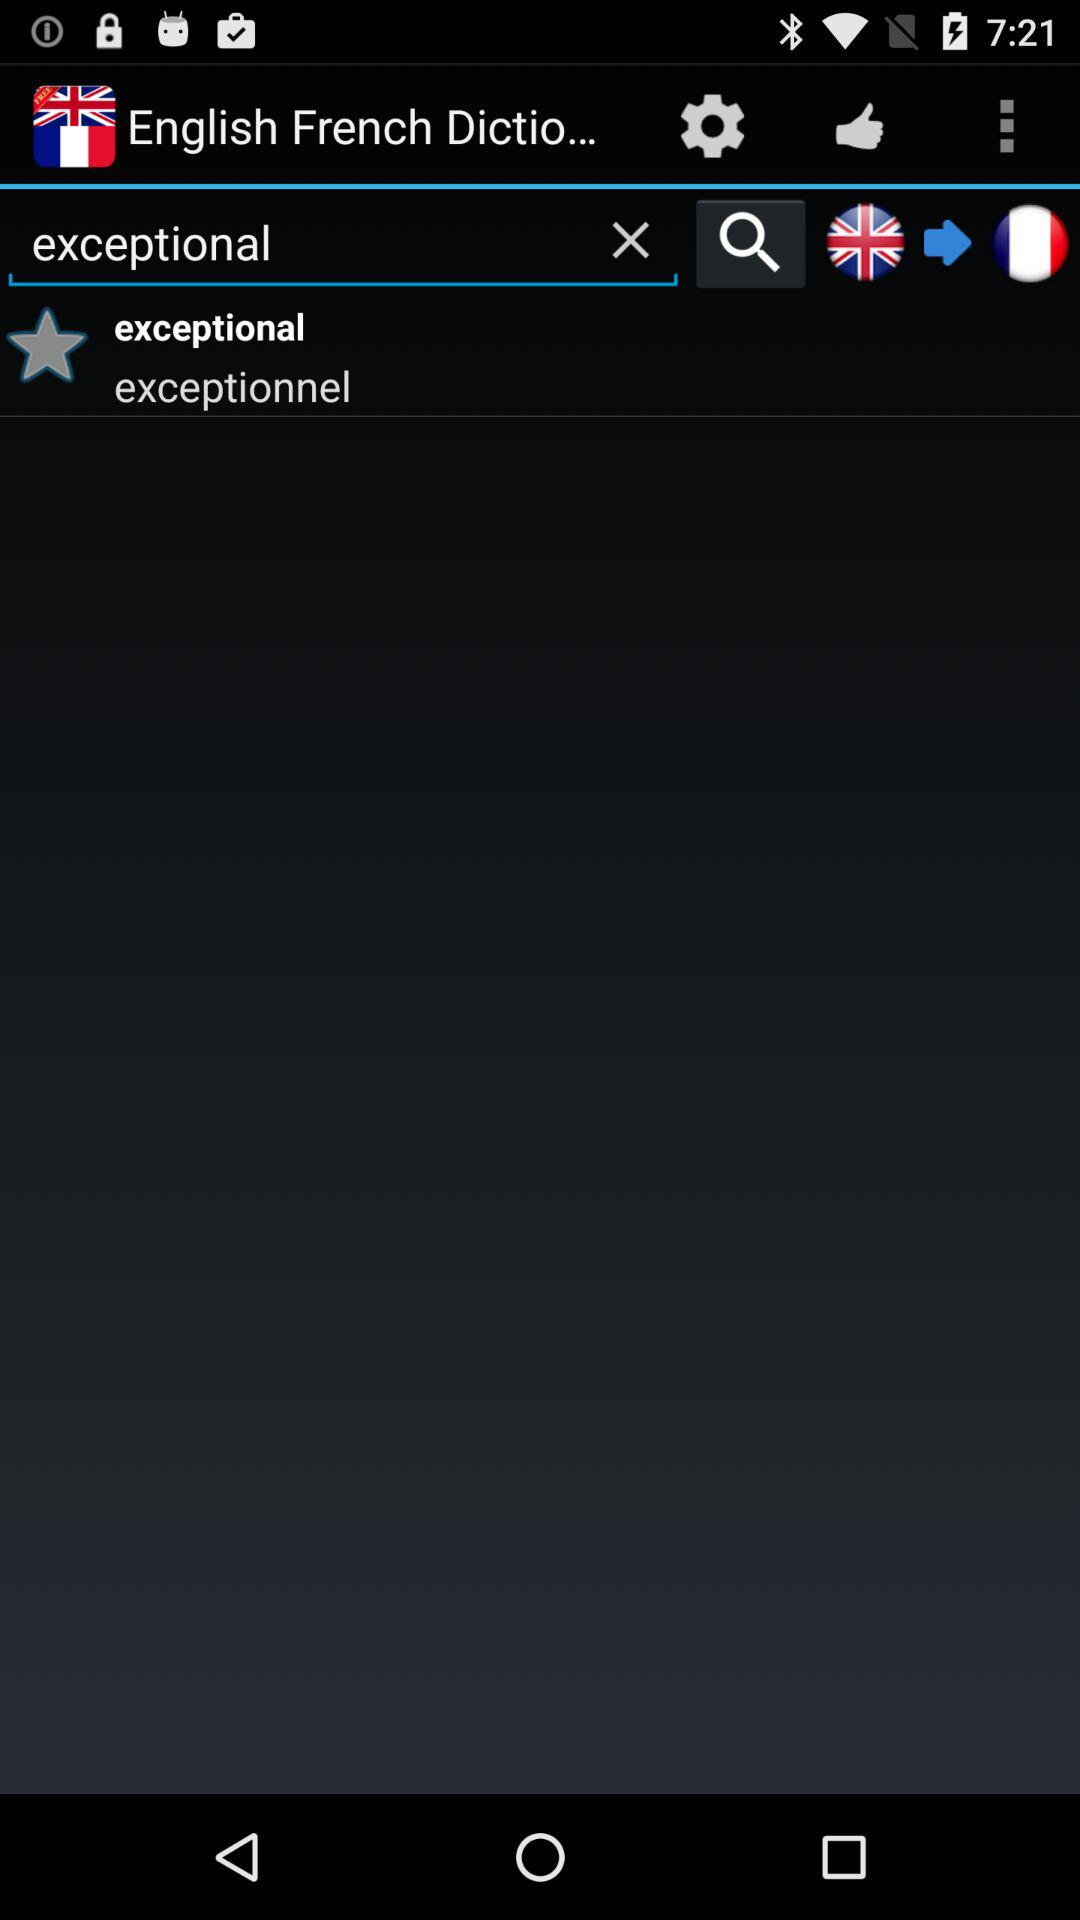What is the dictionary name? The dictionary name is "English French Dictio...". 